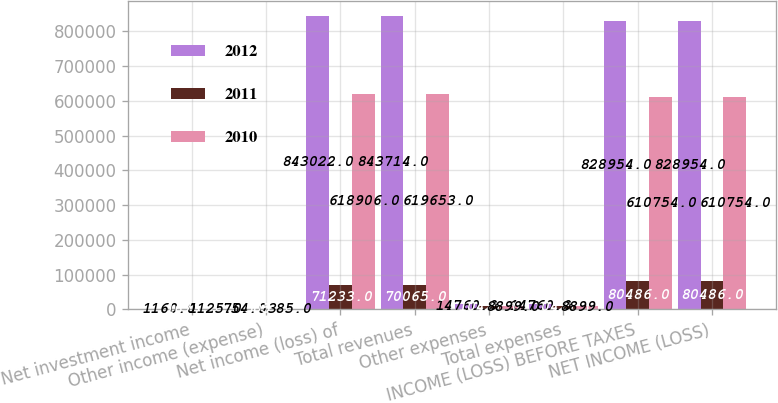Convert chart to OTSL. <chart><loc_0><loc_0><loc_500><loc_500><stacked_bar_chart><ecel><fcel>Net investment income<fcel>Other income (expense)<fcel>Net income (loss) of<fcel>Total revenues<fcel>Other expenses<fcel>Total expenses<fcel>INCOME (LOSS) BEFORE TAXES<fcel>NET INCOME (LOSS)<nl><fcel>2012<fcel>1160<fcel>754<fcel>843022<fcel>843714<fcel>14760<fcel>14760<fcel>828954<fcel>828954<nl><fcel>2011<fcel>1673<fcel>505<fcel>71233<fcel>70065<fcel>10421<fcel>10421<fcel>80486<fcel>80486<nl><fcel>2010<fcel>1125<fcel>385<fcel>618906<fcel>619653<fcel>8899<fcel>8899<fcel>610754<fcel>610754<nl></chart> 